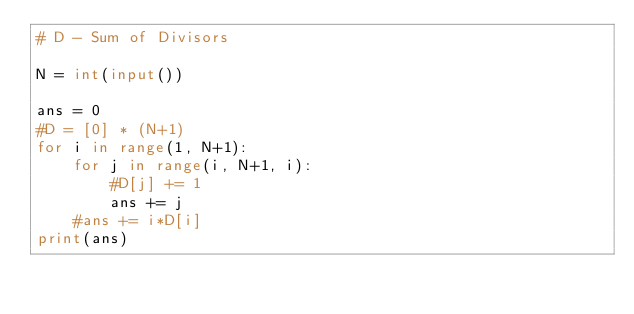Convert code to text. <code><loc_0><loc_0><loc_500><loc_500><_Python_># D - Sum of Divisors

N = int(input())

ans = 0
#D = [0] * (N+1)
for i in range(1, N+1):
    for j in range(i, N+1, i):
        #D[j] += 1
        ans += j
    #ans += i*D[i]
print(ans)</code> 